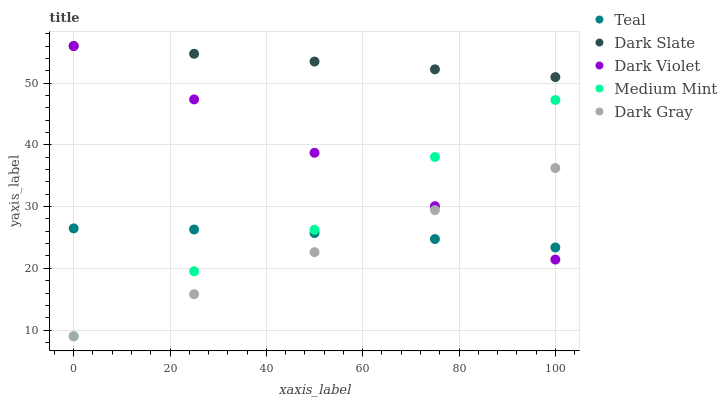Does Dark Gray have the minimum area under the curve?
Answer yes or no. Yes. Does Dark Slate have the maximum area under the curve?
Answer yes or no. Yes. Does Dark Slate have the minimum area under the curve?
Answer yes or no. No. Does Dark Gray have the maximum area under the curve?
Answer yes or no. No. Is Dark Violet the smoothest?
Answer yes or no. Yes. Is Medium Mint the roughest?
Answer yes or no. Yes. Is Dark Slate the smoothest?
Answer yes or no. No. Is Dark Slate the roughest?
Answer yes or no. No. Does Medium Mint have the lowest value?
Answer yes or no. Yes. Does Dark Slate have the lowest value?
Answer yes or no. No. Does Dark Violet have the highest value?
Answer yes or no. Yes. Does Dark Gray have the highest value?
Answer yes or no. No. Is Dark Gray less than Dark Slate?
Answer yes or no. Yes. Is Dark Slate greater than Teal?
Answer yes or no. Yes. Does Teal intersect Medium Mint?
Answer yes or no. Yes. Is Teal less than Medium Mint?
Answer yes or no. No. Is Teal greater than Medium Mint?
Answer yes or no. No. Does Dark Gray intersect Dark Slate?
Answer yes or no. No. 